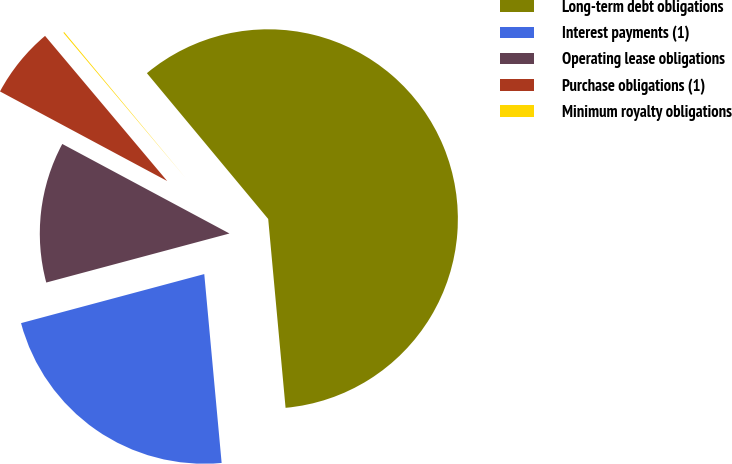Convert chart to OTSL. <chart><loc_0><loc_0><loc_500><loc_500><pie_chart><fcel>Long-term debt obligations<fcel>Interest payments (1)<fcel>Operating lease obligations<fcel>Purchase obligations (1)<fcel>Minimum royalty obligations<nl><fcel>59.59%<fcel>22.3%<fcel>11.99%<fcel>6.04%<fcel>0.09%<nl></chart> 